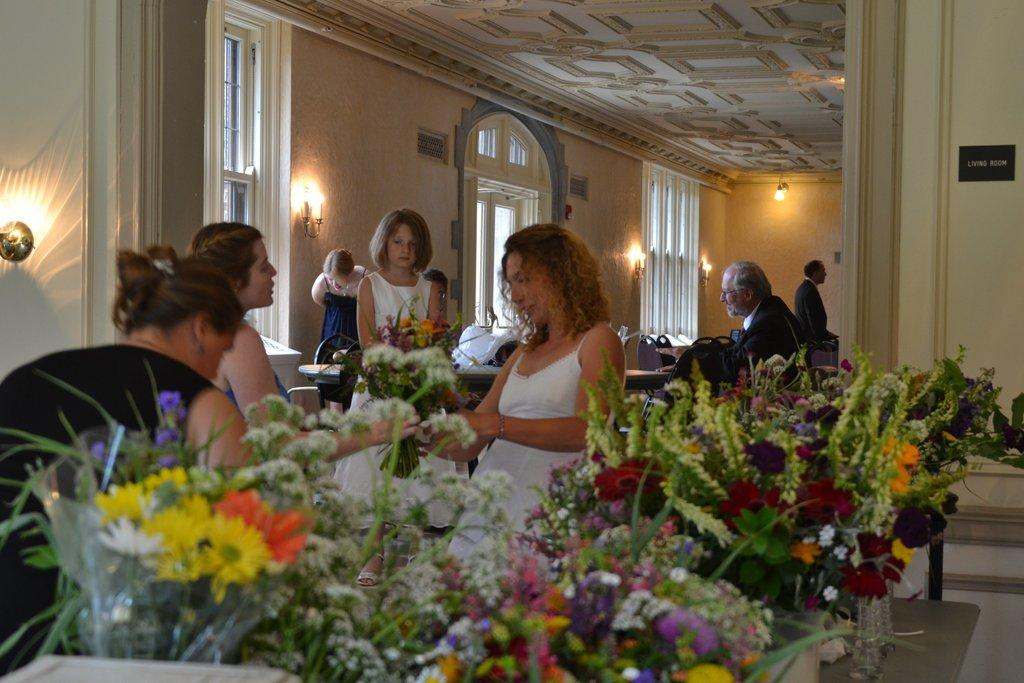How many people are in the image? There are persons in the image, but the exact number cannot be determined from the provided facts. What type of furniture is present in the image? There are tables in the image. What type of decorative or natural elements can be seen in the image? There are flowers in the image. What architectural feature is visible in the image? There is a window in the image. What type of illumination is present in the image? There is light visible in the image. What type of structure is visible in the image? There is a wall visible in the image. How many shoes are visible on the persons in the image? There is no information about shoes or footwear in the provided facts, so it cannot be determined from the image. What type of carriage is present in the image? There is no carriage present in the image; the facts mention only persons, tables, flowers, a window, light, and a wall. 